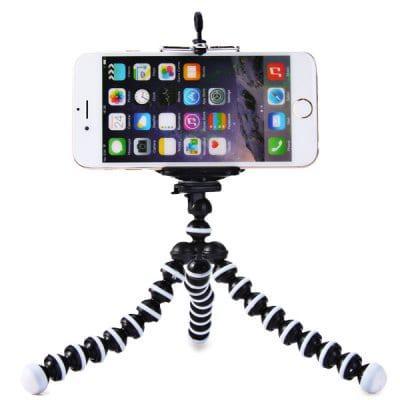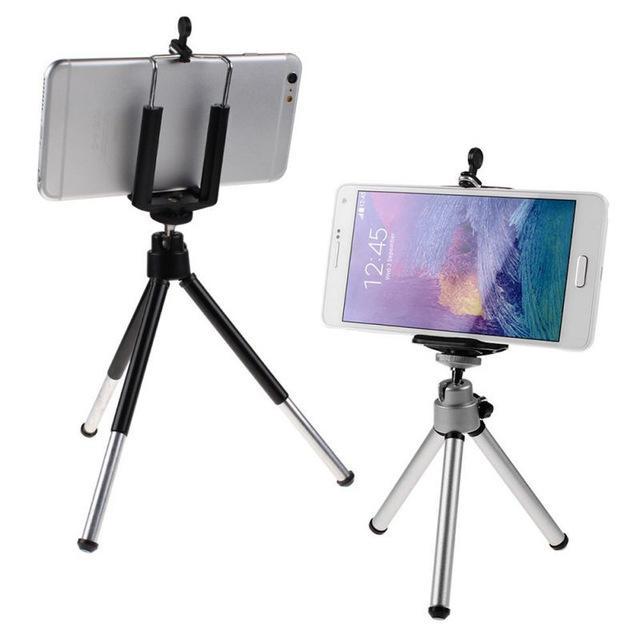The first image is the image on the left, the second image is the image on the right. Examine the images to the left and right. Is the description "There is a total of three cell phones." accurate? Answer yes or no. Yes. The first image is the image on the left, the second image is the image on the right. Evaluate the accuracy of this statement regarding the images: "The back of a phone is visible.". Is it true? Answer yes or no. Yes. 